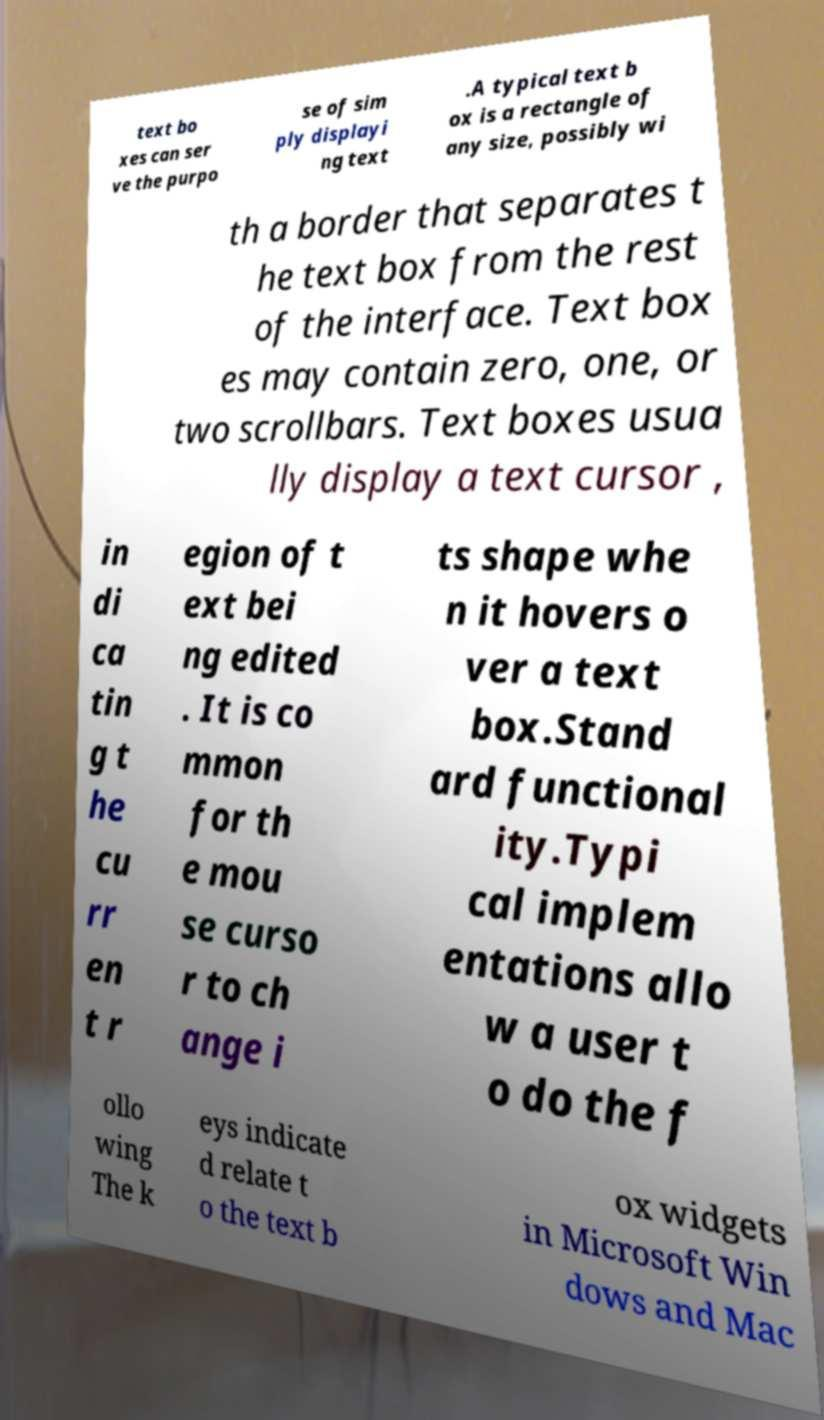Can you read and provide the text displayed in the image?This photo seems to have some interesting text. Can you extract and type it out for me? text bo xes can ser ve the purpo se of sim ply displayi ng text .A typical text b ox is a rectangle of any size, possibly wi th a border that separates t he text box from the rest of the interface. Text box es may contain zero, one, or two scrollbars. Text boxes usua lly display a text cursor , in di ca tin g t he cu rr en t r egion of t ext bei ng edited . It is co mmon for th e mou se curso r to ch ange i ts shape whe n it hovers o ver a text box.Stand ard functional ity.Typi cal implem entations allo w a user t o do the f ollo wing The k eys indicate d relate t o the text b ox widgets in Microsoft Win dows and Mac 